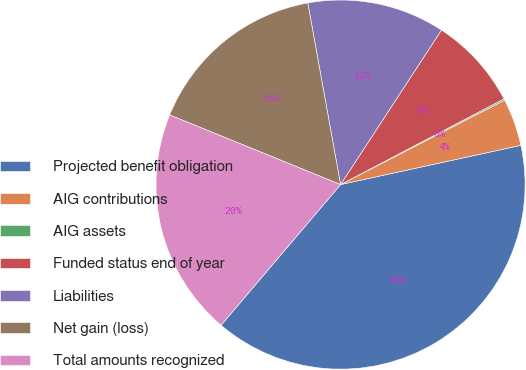Convert chart to OTSL. <chart><loc_0><loc_0><loc_500><loc_500><pie_chart><fcel>Projected benefit obligation<fcel>AIG contributions<fcel>AIG assets<fcel>Funded status end of year<fcel>Liabilities<fcel>Net gain (loss)<fcel>Total amounts recognized<nl><fcel>39.62%<fcel>4.15%<fcel>0.13%<fcel>8.1%<fcel>12.05%<fcel>16.0%<fcel>19.95%<nl></chart> 